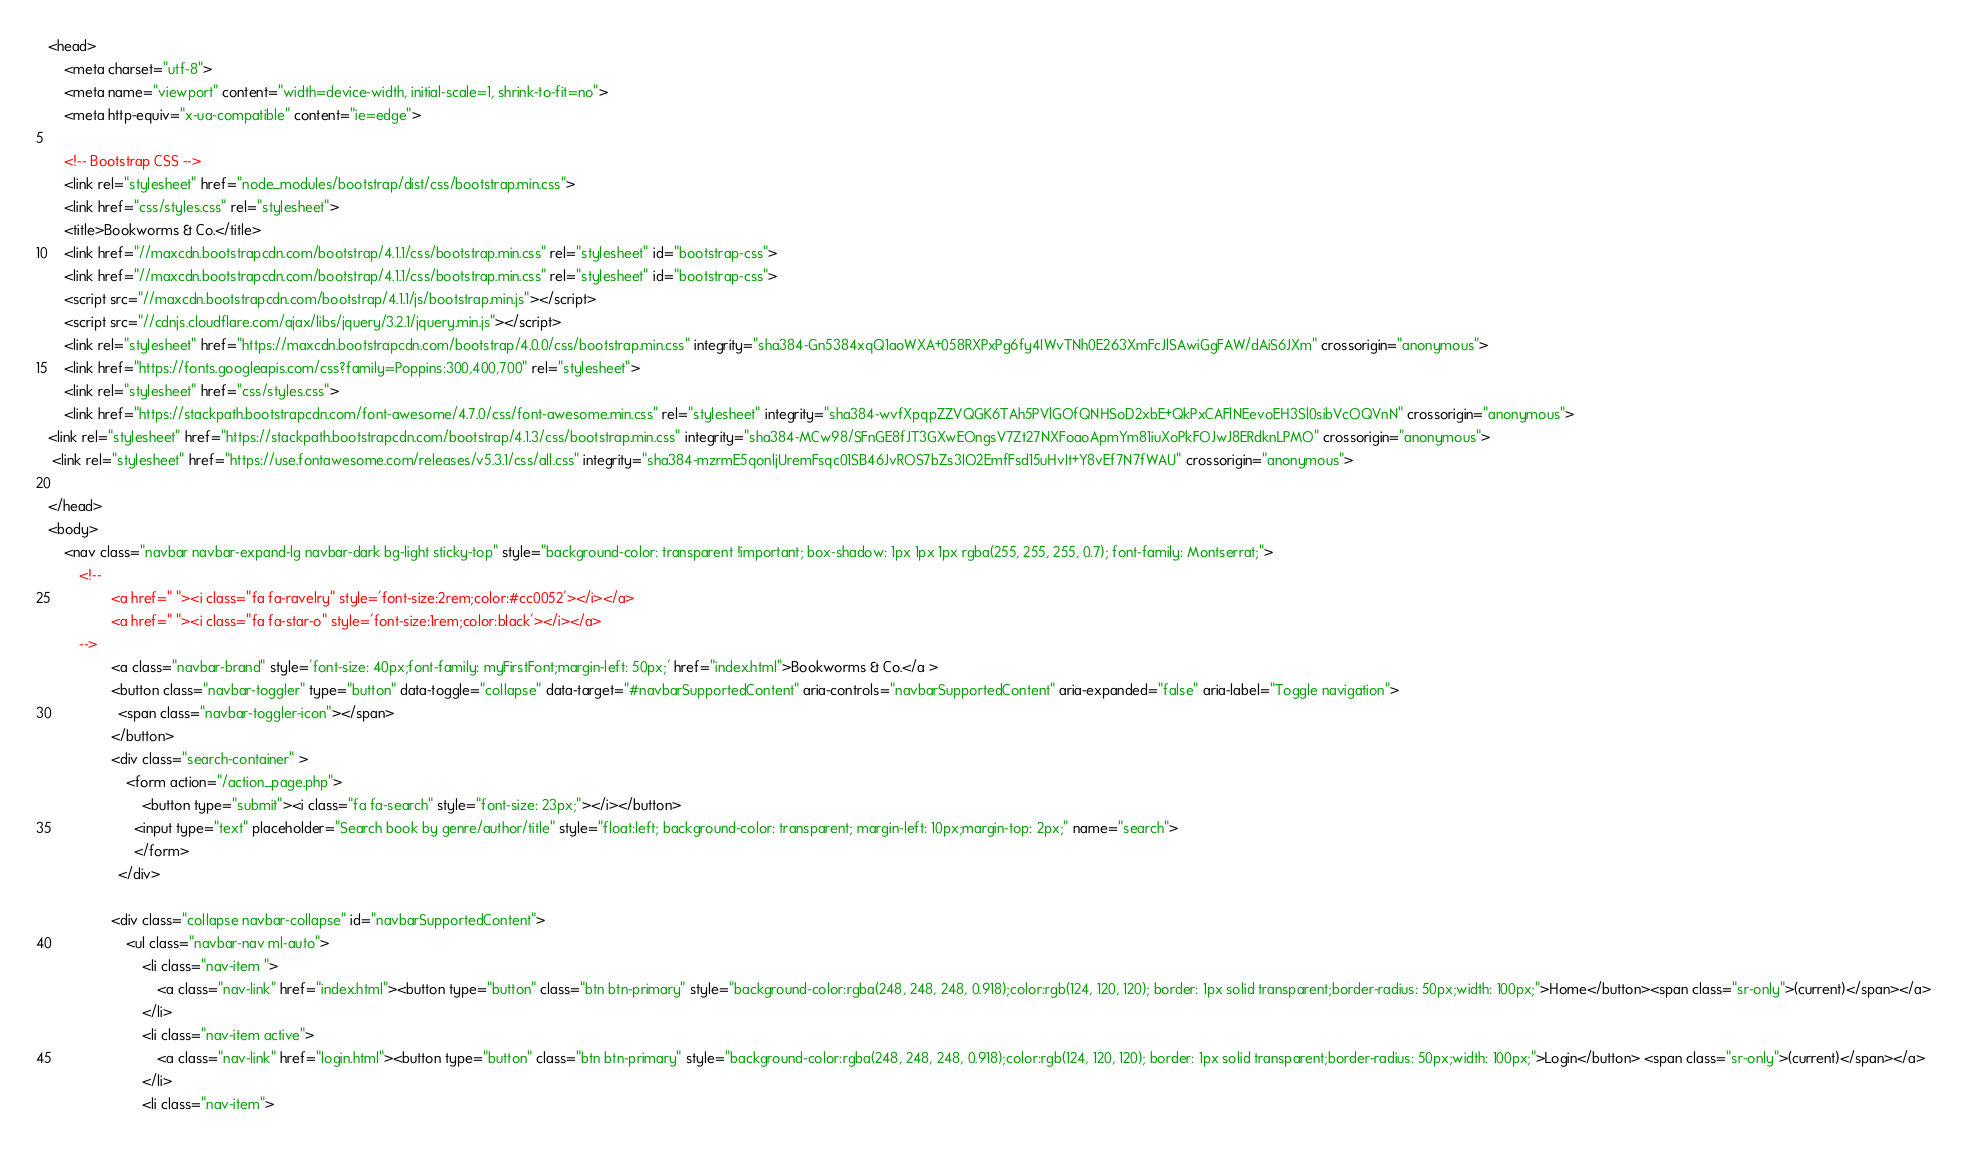Convert code to text. <code><loc_0><loc_0><loc_500><loc_500><_HTML_><head>
    <meta charset="utf-8">
    <meta name="viewport" content="width=device-width, initial-scale=1, shrink-to-fit=no">
    <meta http-equiv="x-ua-compatible" content="ie=edge">

    <!-- Bootstrap CSS -->
    <link rel="stylesheet" href="node_modules/bootstrap/dist/css/bootstrap.min.css">
    <link href="css/styles.css" rel="stylesheet">
    <title>Bookworms & Co.</title>
    <link href="//maxcdn.bootstrapcdn.com/bootstrap/4.1.1/css/bootstrap.min.css" rel="stylesheet" id="bootstrap-css">
    <link href="//maxcdn.bootstrapcdn.com/bootstrap/4.1.1/css/bootstrap.min.css" rel="stylesheet" id="bootstrap-css">
    <script src="//maxcdn.bootstrapcdn.com/bootstrap/4.1.1/js/bootstrap.min.js"></script>
    <script src="//cdnjs.cloudflare.com/ajax/libs/jquery/3.2.1/jquery.min.js"></script>
    <link rel="stylesheet" href="https://maxcdn.bootstrapcdn.com/bootstrap/4.0.0/css/bootstrap.min.css" integrity="sha384-Gn5384xqQ1aoWXA+058RXPxPg6fy4IWvTNh0E263XmFcJlSAwiGgFAW/dAiS6JXm" crossorigin="anonymous">
    <link href="https://fonts.googleapis.com/css?family=Poppins:300,400,700" rel="stylesheet">
    <link rel="stylesheet" href="css/styles.css">
    <link href="https://stackpath.bootstrapcdn.com/font-awesome/4.7.0/css/font-awesome.min.css" rel="stylesheet" integrity="sha384-wvfXpqpZZVQGK6TAh5PVlGOfQNHSoD2xbE+QkPxCAFlNEevoEH3Sl0sibVcOQVnN" crossorigin="anonymous">
<link rel="stylesheet" href="https://stackpath.bootstrapcdn.com/bootstrap/4.1.3/css/bootstrap.min.css" integrity="sha384-MCw98/SFnGE8fJT3GXwEOngsV7Zt27NXFoaoApmYm81iuXoPkFOJwJ8ERdknLPMO" crossorigin="anonymous">
 <link rel="stylesheet" href="https://use.fontawesome.com/releases/v5.3.1/css/all.css" integrity="sha384-mzrmE5qonljUremFsqc01SB46JvROS7bZs3IO2EmfFsd15uHvIt+Y8vEf7N7fWAU" crossorigin="anonymous">

</head>
<body>
	<nav class="navbar navbar-expand-lg navbar-dark bg-light sticky-top" style="background-color: transparent !important; box-shadow: 1px 1px 1px rgba(255, 255, 255, 0.7); font-family: Montserrat;">
		<!--
				<a href=" "><i class="fa fa-ravelry" style='font-size:2rem;color:#cc0052'></i></a>
				<a href=" "><i class="fa fa-star-o" style='font-size:1rem;color:black'></i></a>
		-->
				<a class="navbar-brand" style='font-size: 40px;font-family: myFirstFont;margin-left: 50px;' href="index.html">Bookworms & Co.</a >
				<button class="navbar-toggler" type="button" data-toggle="collapse" data-target="#navbarSupportedContent" aria-controls="navbarSupportedContent" aria-expanded="false" aria-label="Toggle navigation">
				  <span class="navbar-toggler-icon"></span>
				</button>
				<div class="search-container" >
					<form action="/action_page.php">
						<button type="submit"><i class="fa fa-search" style="font-size: 23px;"></i></button>
					  <input type="text" placeholder="Search book by genre/author/title" style="float:left; background-color: transparent; margin-left: 10px;margin-top: 2px;" name="search">
					  </form>
				  </div>
		
				<div class="collapse navbar-collapse" id="navbarSupportedContent">
					<ul class="navbar-nav ml-auto">
						<li class="nav-item ">
							<a class="nav-link" href="index.html"><button type="button" class="btn btn-primary" style="background-color:rgba(248, 248, 248, 0.918);color:rgb(124, 120, 120); border: 1px solid transparent;border-radius: 50px;width: 100px;">Home</button><span class="sr-only">(current)</span></a>
						</li>
						<li class="nav-item active">
							<a class="nav-link" href="login.html"><button type="button" class="btn btn-primary" style="background-color:rgba(248, 248, 248, 0.918);color:rgb(124, 120, 120); border: 1px solid transparent;border-radius: 50px;width: 100px;">Login</button> <span class="sr-only">(current)</span></a>
						</li>
						<li class="nav-item"></code> 